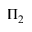Convert formula to latex. <formula><loc_0><loc_0><loc_500><loc_500>\Pi _ { 2 }</formula> 